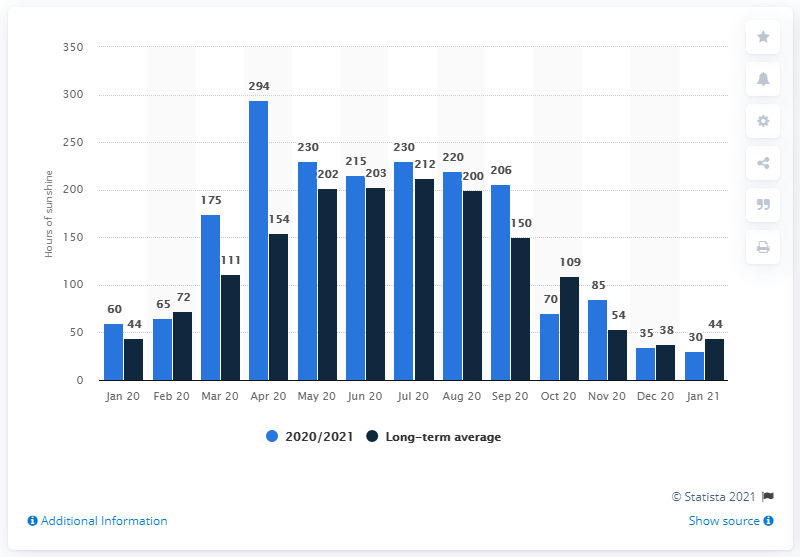List a handful of essential elements in this visual. In January 2021, the average amount of sunshine hours in Germany was approximately 30 hours per day. 